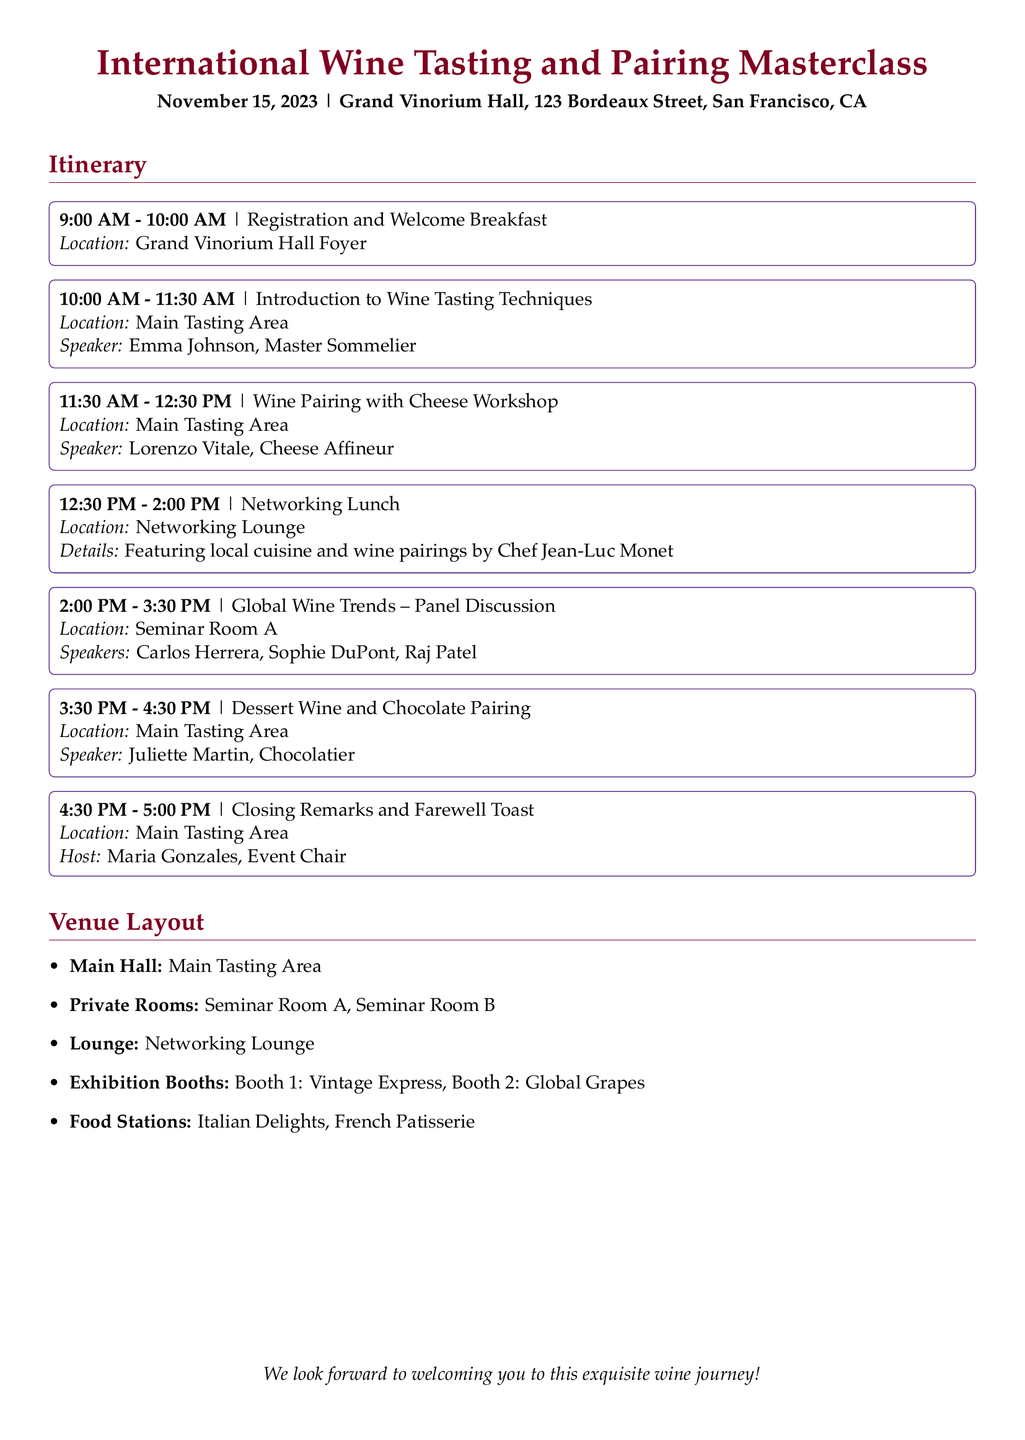What time does the event start? The start time of the event is indicated at the beginning of the itinerary, which is 9:00 AM.
Answer: 9:00 AM Who is the speaker for the introductory session? The speaker for the introductory session is mentioned in the document, specifically in the section about the Introduction to Wine Tasting Techniques.
Answer: Emma Johnson What is the location for the networking lunch? The location for the networking lunch is specified in the itinerary as the Networking Lounge.
Answer: Networking Lounge What type of cuisine will be featured during the lunch? The details about the lunch specify the type of cuisine that will be served, which is local cuisine.
Answer: Local cuisine Which session includes a panel discussion? The session that involves a discussion among multiple speakers is identified as the Global Wine Trends session.
Answer: Global Wine Trends How many speakers are there for the panel discussion? The number of speakers for the panel discussion is noted in that section of the document, which lists three speakers.
Answer: Three What is the name of the host for the closing remarks? The name of the host for the closing remarks is provided in the final section of the itinerary, which is Maria Gonzales.
Answer: Maria Gonzales Which booth features Vintage Express? The information regarding exhibitions lists booths and their respective names, specifically identifying which one features Vintage Express.
Answer: Booth 1 What is the time duration for the workshop on wine pairing? The time allocated for the wine pairing workshop is clearly stated in the itinerary, which shows a duration of one hour.
Answer: One hour 